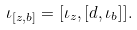Convert formula to latex. <formula><loc_0><loc_0><loc_500><loc_500>\iota _ { [ z , b ] } = [ \iota _ { z } , [ d , \iota _ { b } ] ] .</formula> 